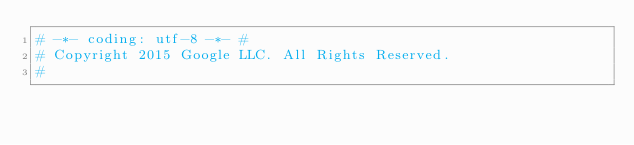<code> <loc_0><loc_0><loc_500><loc_500><_Python_># -*- coding: utf-8 -*- #
# Copyright 2015 Google LLC. All Rights Reserved.
#</code> 